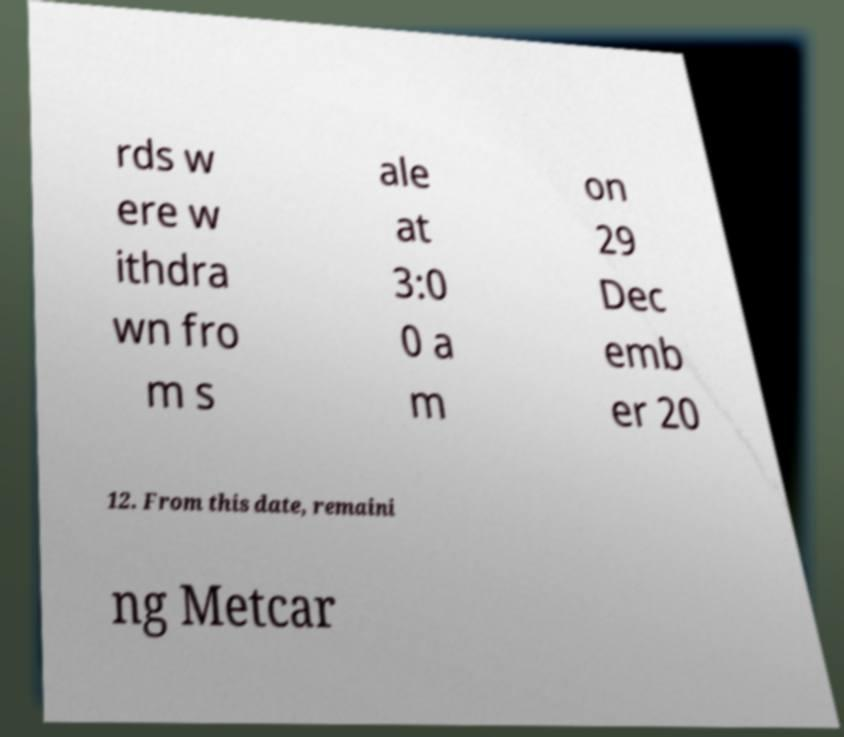Please identify and transcribe the text found in this image. rds w ere w ithdra wn fro m s ale at 3:0 0 a m on 29 Dec emb er 20 12. From this date, remaini ng Metcar 